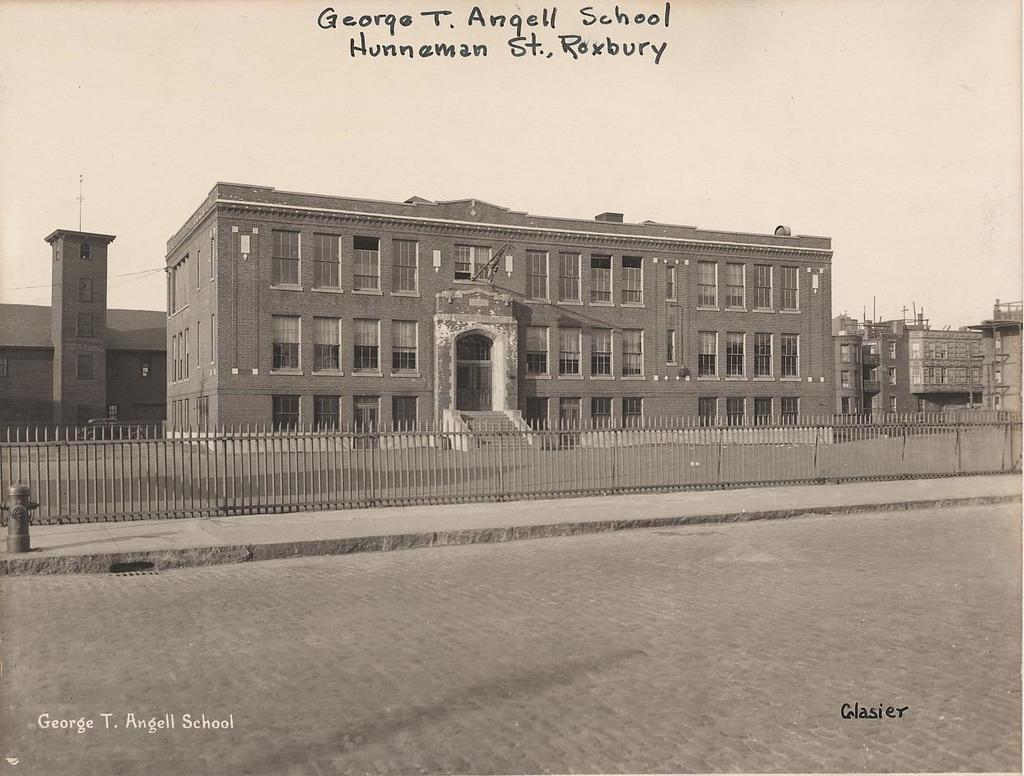What is the color scheme of the image? The image is black and white. What can be seen in the foreground of the image? There is a road in the foreground of the image. What is located in the center of the image? There are buildings, a railing, and a footpath in the center of the image. What is the weather like in the image? The sky is sunny in the image. What is present at the top of the image? There is text at the top of the image. What type of wool is being used to create the tree in the image? There is no tree present in the image, and therefore no wool is being used to create it. What type of drink is being served in the image? There is no drink being served in the image. 